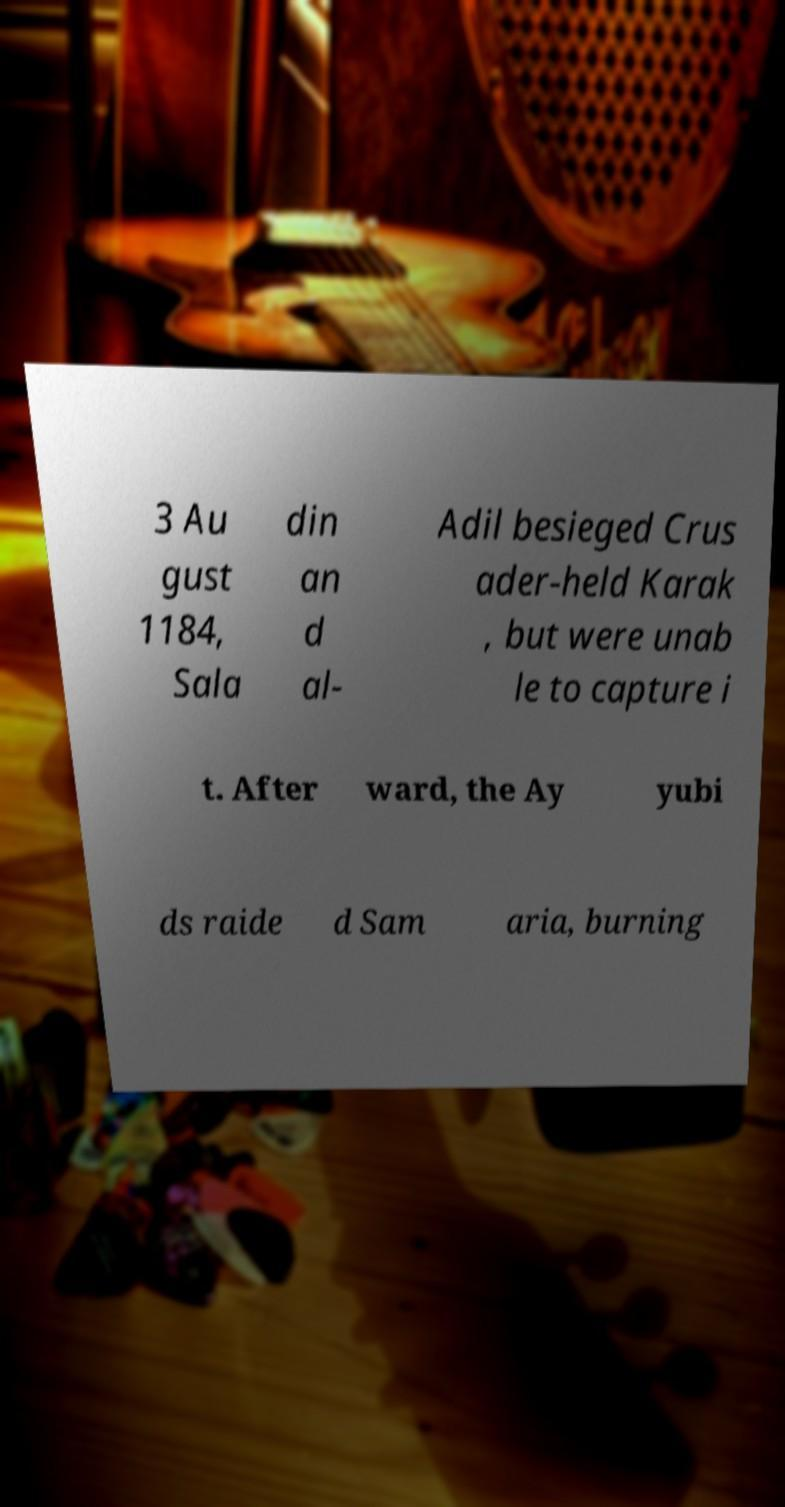Please identify and transcribe the text found in this image. 3 Au gust 1184, Sala din an d al- Adil besieged Crus ader-held Karak , but were unab le to capture i t. After ward, the Ay yubi ds raide d Sam aria, burning 